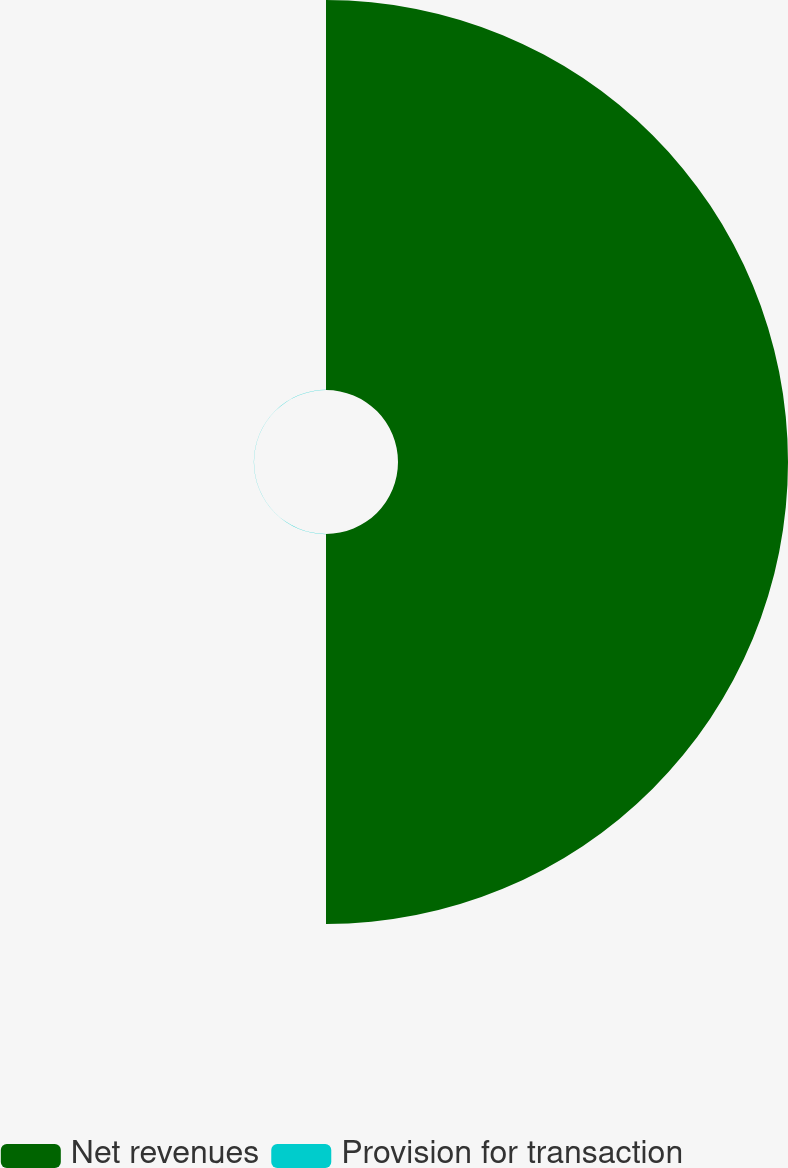<chart> <loc_0><loc_0><loc_500><loc_500><pie_chart><fcel>Net revenues<fcel>Provision for transaction<nl><fcel>99.96%<fcel>0.04%<nl></chart> 